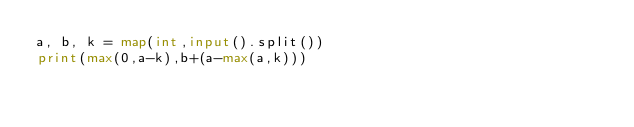<code> <loc_0><loc_0><loc_500><loc_500><_Python_>a, b, k = map(int,input().split())
print(max(0,a-k),b+(a-max(a,k)))</code> 